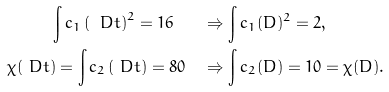Convert formula to latex. <formula><loc_0><loc_0><loc_500><loc_500>\int c _ { 1 } \left ( \ D t \right ) ^ { 2 } = 1 6 \quad & \Rightarrow \int c _ { 1 } ( D ) ^ { 2 } = 2 , \\ \chi ( \ D t ) = \int c _ { 2 } \left ( \ D t \right ) = 8 0 \quad & \Rightarrow \int c _ { 2 } ( D ) = 1 0 = \chi ( D ) .</formula> 